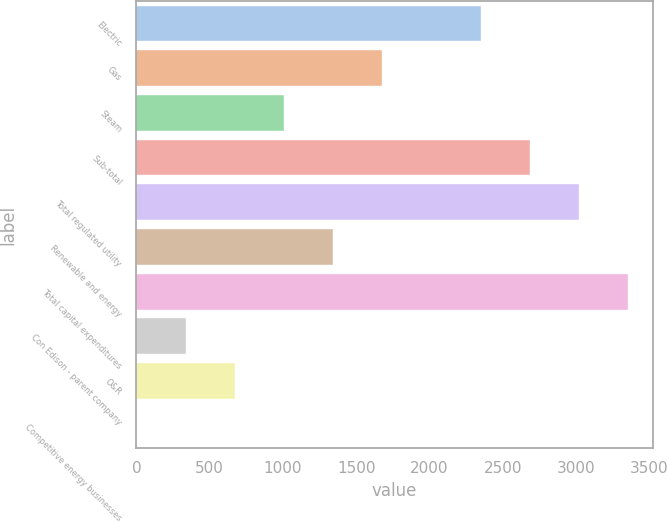Convert chart. <chart><loc_0><loc_0><loc_500><loc_500><bar_chart><fcel>Electric<fcel>Gas<fcel>Steam<fcel>Sub-total<fcel>Total regulated utility<fcel>Renewable and energy<fcel>Total capital expenditures<fcel>Con Edison - parent company<fcel>O&R<fcel>Competitive energy businesses<nl><fcel>2348.1<fcel>1677.5<fcel>1006.9<fcel>2683.4<fcel>3018.7<fcel>1342.2<fcel>3354<fcel>336.3<fcel>671.6<fcel>1<nl></chart> 